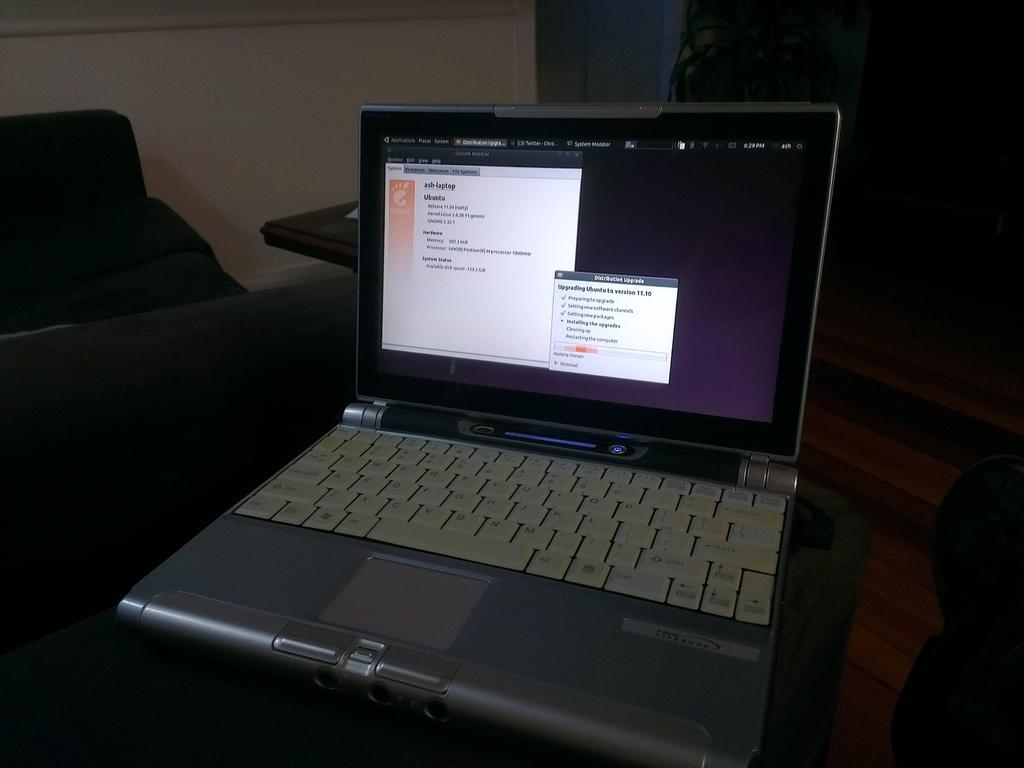What electronic device is visible in the image? There is a laptop in the image. What type of furniture is on the left side of the image? There is a chair on the left side of the image. What is in front of the chair? There is a table in front of the chair. What can be seen in the background of the image? There is a wall and a plant in the background of the image. What is the taste of the park mentioned in the image? There is no mention of a park in the image, and therefore no taste can be associated with it. 